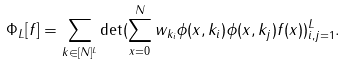Convert formula to latex. <formula><loc_0><loc_0><loc_500><loc_500>\Phi _ { L } [ f ] = \sum _ { k \in [ N ] ^ { L } } \det ( \sum _ { x = 0 } ^ { N } w _ { k _ { i } } \phi ( x , k _ { i } ) \phi ( x , k _ { j } ) f ( x ) ) _ { i , j = 1 } ^ { L } .</formula> 